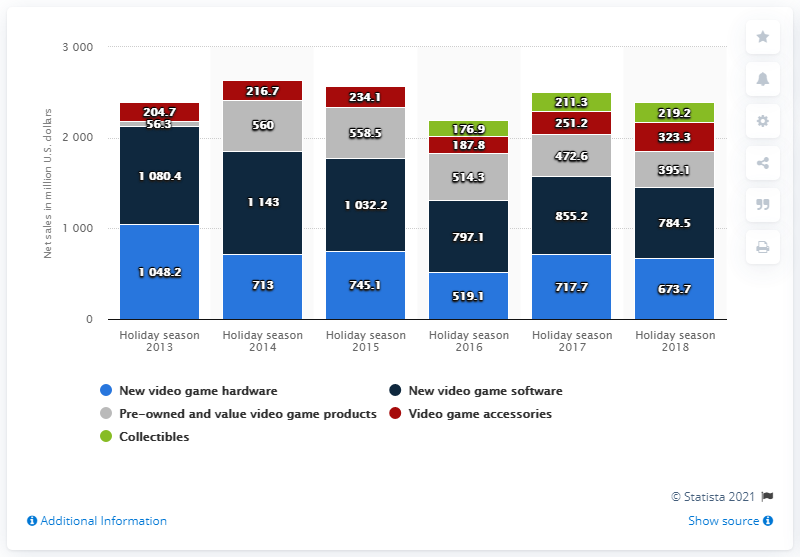Identify some key points in this picture. GameStop's net sales of new video game hardware products from 2013 to 2018 were 673.7, 718.3, 656.4, 702.2, and 639.8 million, respectively. The average of video game accessories, minus the median of collectibles, results in a value of 25. The second largest red bar is 251.2. 